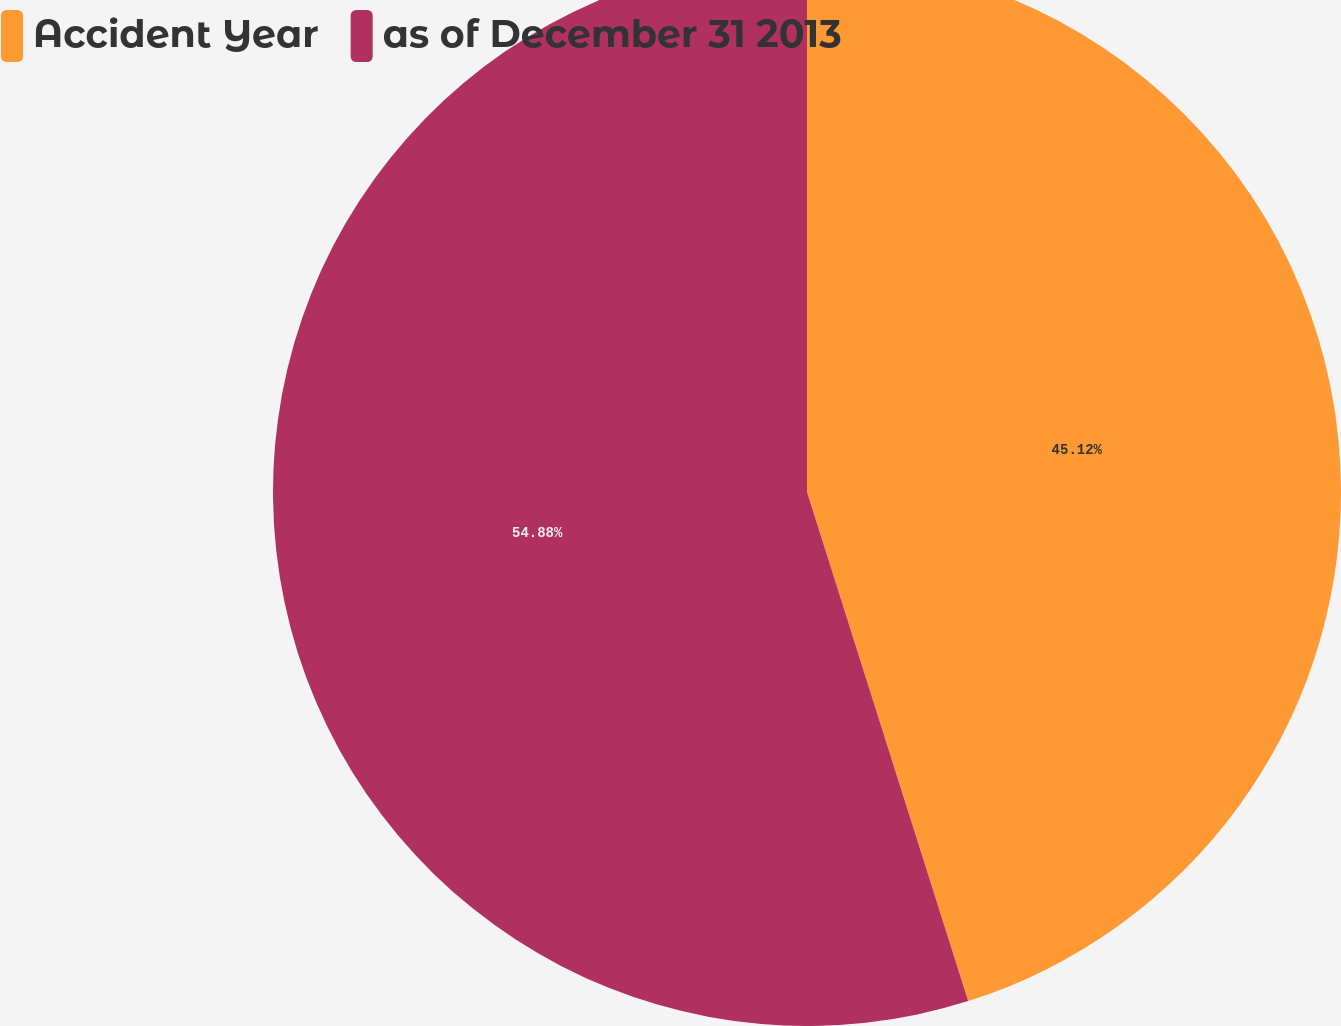Convert chart to OTSL. <chart><loc_0><loc_0><loc_500><loc_500><pie_chart><fcel>Accident Year<fcel>as of December 31 2013<nl><fcel>45.12%<fcel>54.88%<nl></chart> 